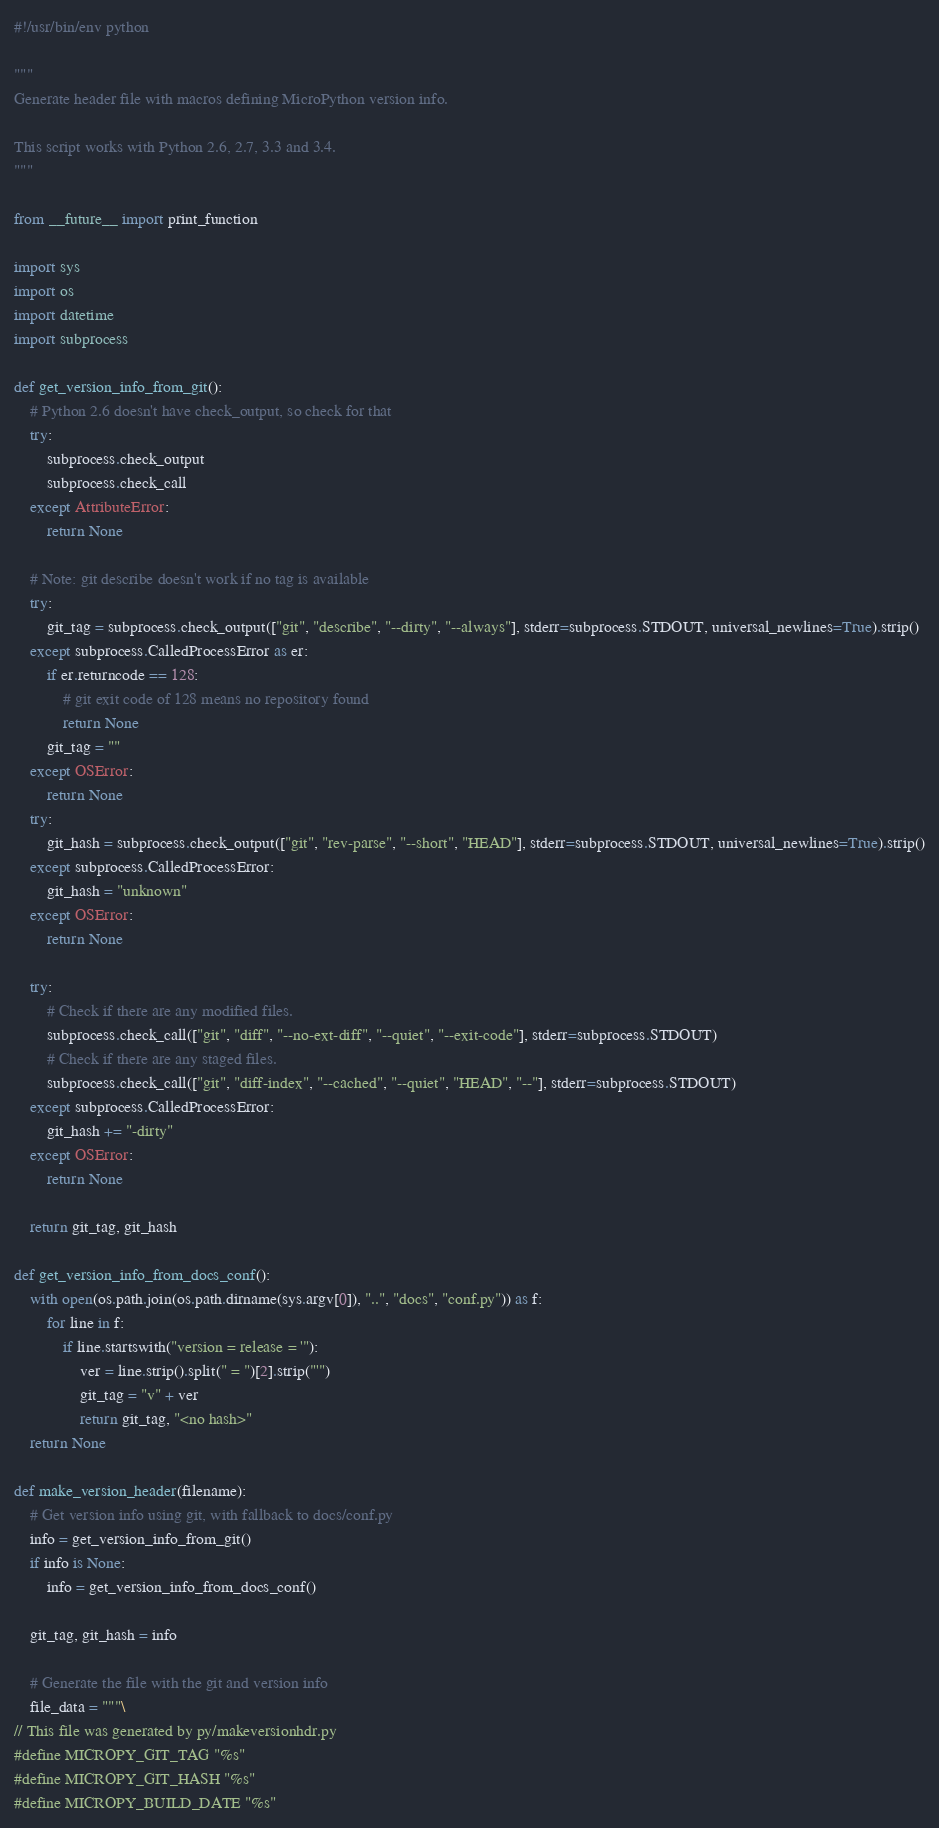<code> <loc_0><loc_0><loc_500><loc_500><_Python_>#!/usr/bin/env python

"""
Generate header file with macros defining MicroPython version info.

This script works with Python 2.6, 2.7, 3.3 and 3.4.
"""

from __future__ import print_function

import sys
import os
import datetime
import subprocess

def get_version_info_from_git():
    # Python 2.6 doesn't have check_output, so check for that
    try:
        subprocess.check_output
        subprocess.check_call
    except AttributeError:
        return None

    # Note: git describe doesn't work if no tag is available
    try:
        git_tag = subprocess.check_output(["git", "describe", "--dirty", "--always"], stderr=subprocess.STDOUT, universal_newlines=True).strip()
    except subprocess.CalledProcessError as er:
        if er.returncode == 128:
            # git exit code of 128 means no repository found
            return None
        git_tag = ""
    except OSError:
        return None
    try:
        git_hash = subprocess.check_output(["git", "rev-parse", "--short", "HEAD"], stderr=subprocess.STDOUT, universal_newlines=True).strip()
    except subprocess.CalledProcessError:
        git_hash = "unknown"
    except OSError:
        return None

    try:
        # Check if there are any modified files.
        subprocess.check_call(["git", "diff", "--no-ext-diff", "--quiet", "--exit-code"], stderr=subprocess.STDOUT)
        # Check if there are any staged files.
        subprocess.check_call(["git", "diff-index", "--cached", "--quiet", "HEAD", "--"], stderr=subprocess.STDOUT)
    except subprocess.CalledProcessError:
        git_hash += "-dirty"
    except OSError:
        return None

    return git_tag, git_hash

def get_version_info_from_docs_conf():
    with open(os.path.join(os.path.dirname(sys.argv[0]), "..", "docs", "conf.py")) as f:
        for line in f:
            if line.startswith("version = release = '"):
                ver = line.strip().split(" = ")[2].strip("'")
                git_tag = "v" + ver
                return git_tag, "<no hash>"
    return None

def make_version_header(filename):
    # Get version info using git, with fallback to docs/conf.py
    info = get_version_info_from_git()
    if info is None:
        info = get_version_info_from_docs_conf()

    git_tag, git_hash = info

    # Generate the file with the git and version info
    file_data = """\
// This file was generated by py/makeversionhdr.py
#define MICROPY_GIT_TAG "%s"
#define MICROPY_GIT_HASH "%s"
#define MICROPY_BUILD_DATE "%s"</code> 